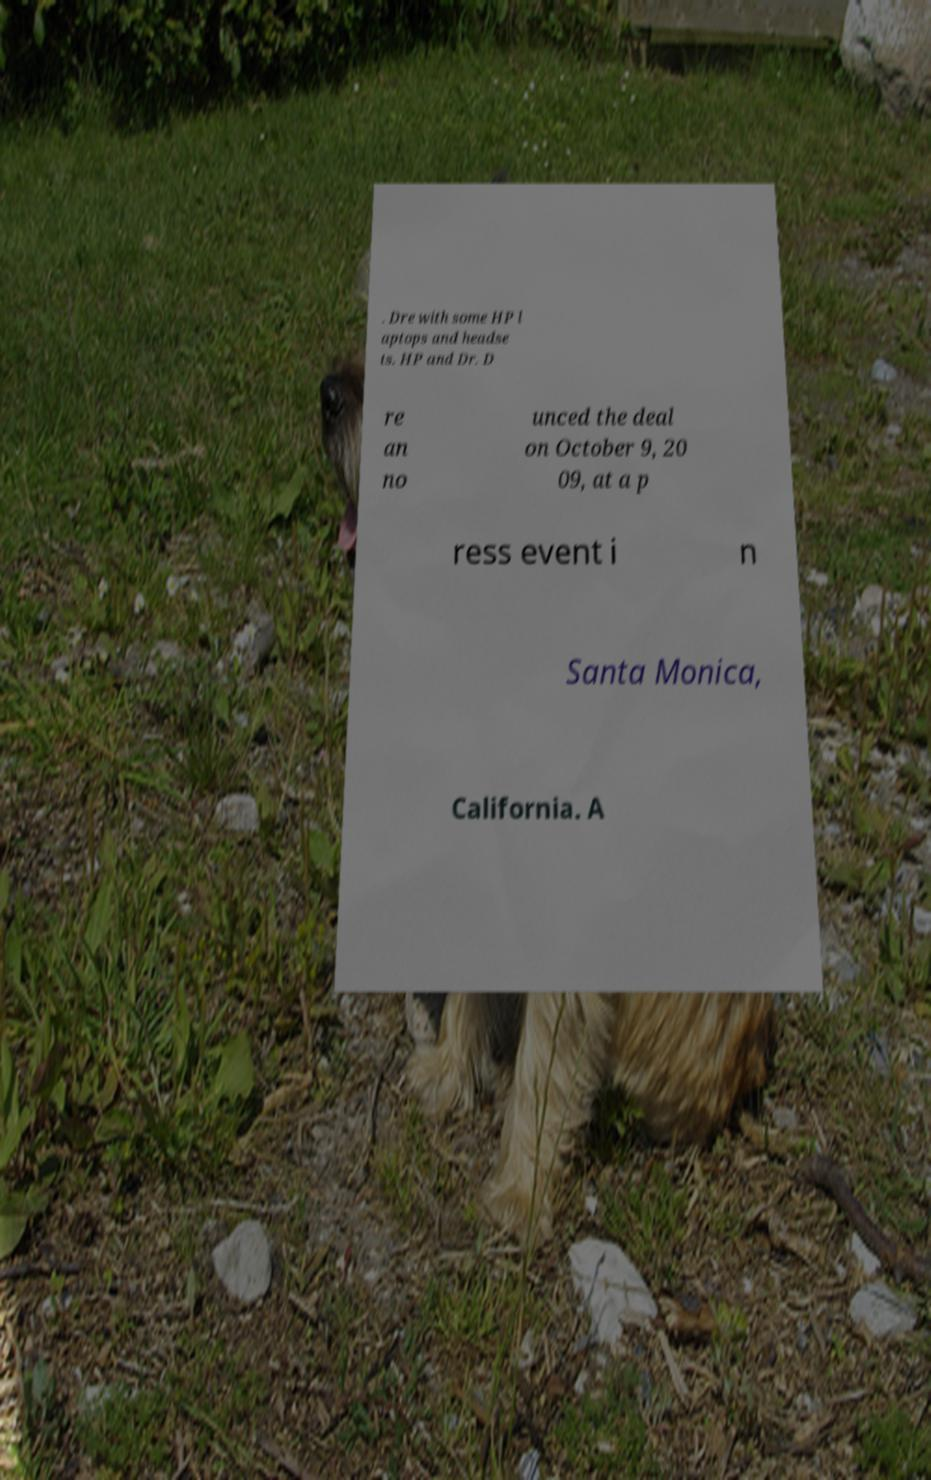There's text embedded in this image that I need extracted. Can you transcribe it verbatim? . Dre with some HP l aptops and headse ts. HP and Dr. D re an no unced the deal on October 9, 20 09, at a p ress event i n Santa Monica, California. A 